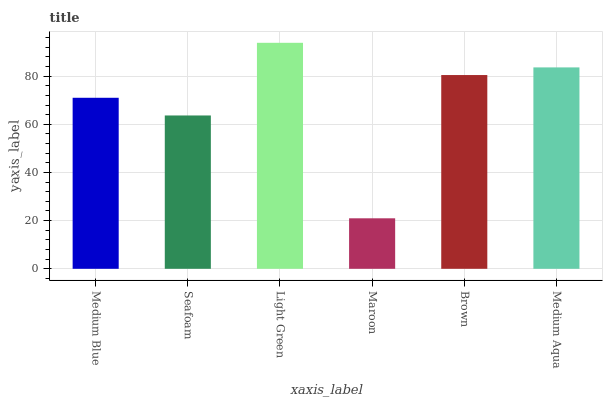Is Maroon the minimum?
Answer yes or no. Yes. Is Light Green the maximum?
Answer yes or no. Yes. Is Seafoam the minimum?
Answer yes or no. No. Is Seafoam the maximum?
Answer yes or no. No. Is Medium Blue greater than Seafoam?
Answer yes or no. Yes. Is Seafoam less than Medium Blue?
Answer yes or no. Yes. Is Seafoam greater than Medium Blue?
Answer yes or no. No. Is Medium Blue less than Seafoam?
Answer yes or no. No. Is Brown the high median?
Answer yes or no. Yes. Is Medium Blue the low median?
Answer yes or no. Yes. Is Seafoam the high median?
Answer yes or no. No. Is Light Green the low median?
Answer yes or no. No. 